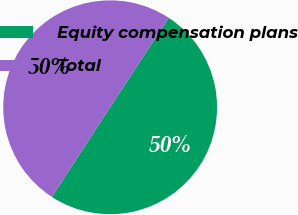Convert chart to OTSL. <chart><loc_0><loc_0><loc_500><loc_500><pie_chart><fcel>Equity compensation plans<fcel>Total<nl><fcel>49.94%<fcel>50.06%<nl></chart> 